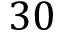Convert formula to latex. <formula><loc_0><loc_0><loc_500><loc_500>3 0</formula> 